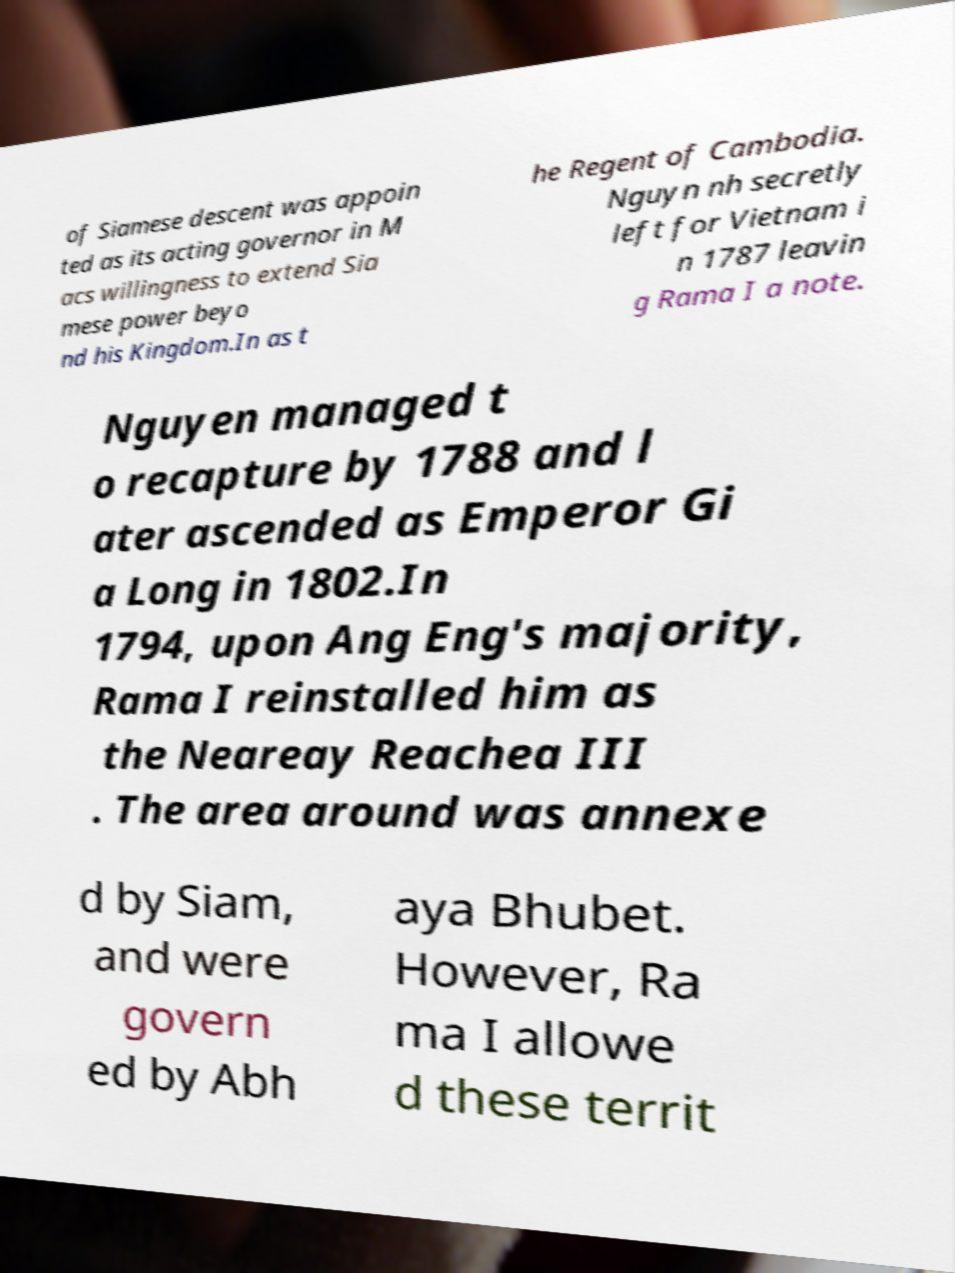Could you assist in decoding the text presented in this image and type it out clearly? of Siamese descent was appoin ted as its acting governor in M acs willingness to extend Sia mese power beyo nd his Kingdom.In as t he Regent of Cambodia. Nguyn nh secretly left for Vietnam i n 1787 leavin g Rama I a note. Nguyen managed t o recapture by 1788 and l ater ascended as Emperor Gi a Long in 1802.In 1794, upon Ang Eng's majority, Rama I reinstalled him as the Neareay Reachea III . The area around was annexe d by Siam, and were govern ed by Abh aya Bhubet. However, Ra ma I allowe d these territ 